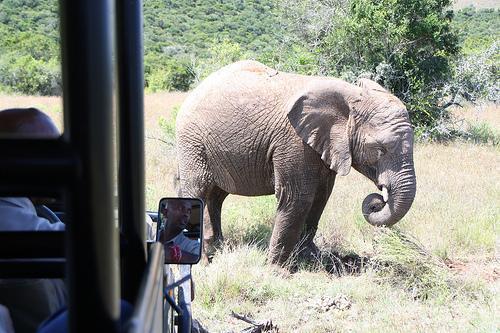How many elephants are in the picture?
Give a very brief answer. 1. How many people do you see?
Give a very brief answer. 1. 